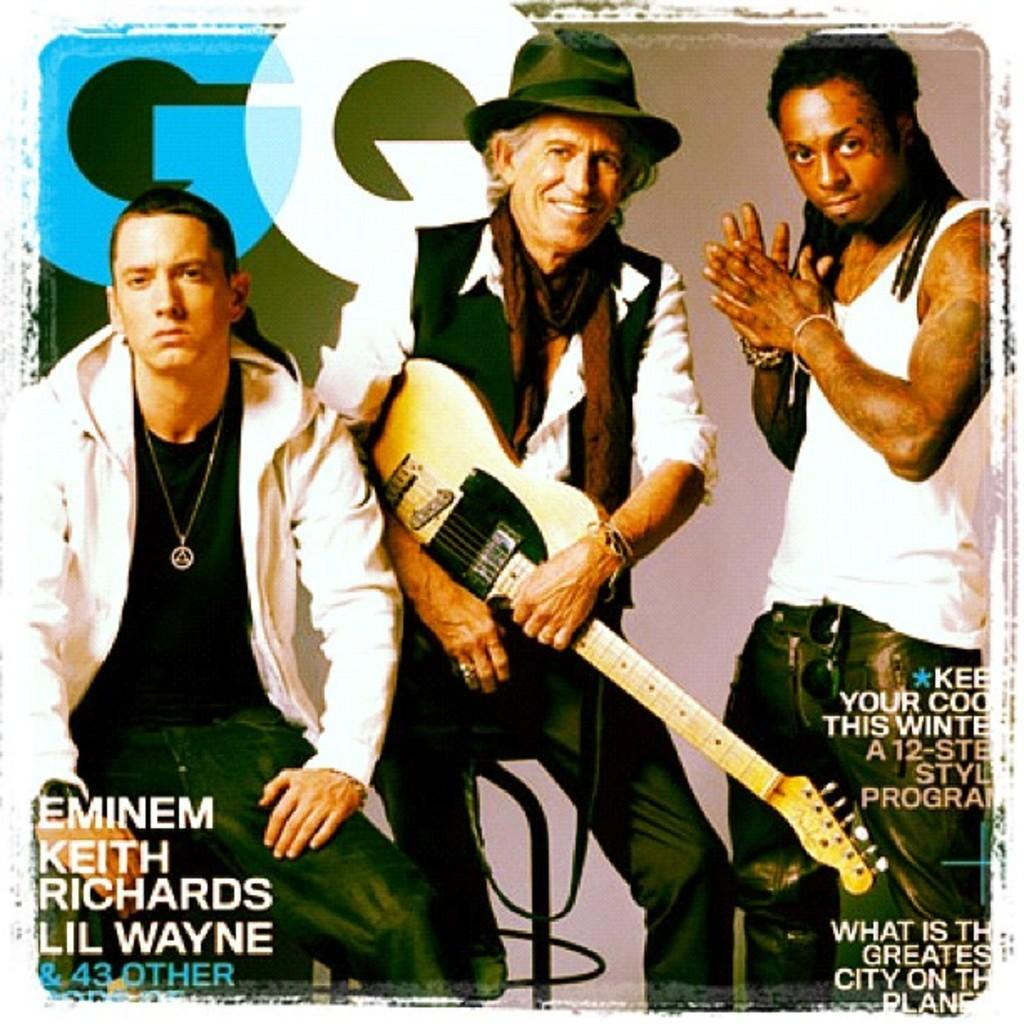What type of image is being described? The image is a magazine poster. How many people are in the image? There are three men in the image. What are the positions of the men in the image? Two of the men are seated, and one person is standing. What is the second seated man holding? The second seated man is holding a guitar. Can you tell me what type of soup the kitten is eating in the image? There is no kitten or soup present in the image. 